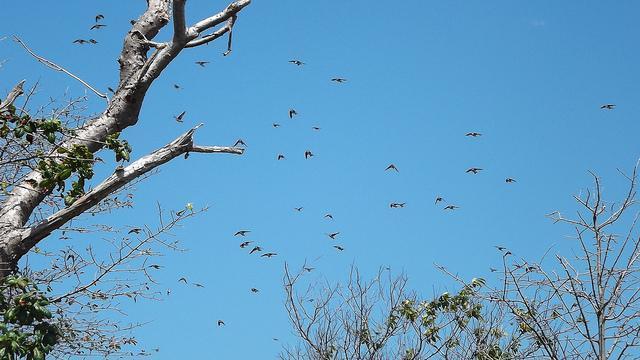How many people are in the photo?
Give a very brief answer. 0. 